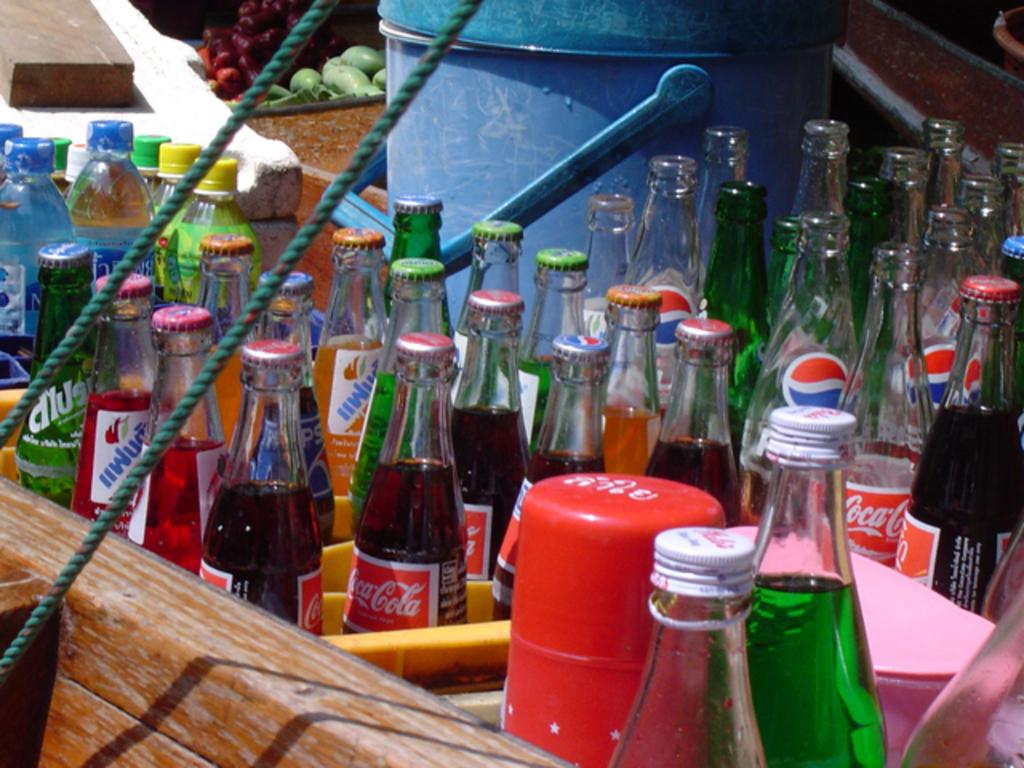<image>
Give a short and clear explanation of the subsequent image. The bins have a lot of Coke and Pepsi bottles 